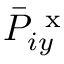Convert formula to latex. <formula><loc_0><loc_0><loc_500><loc_500>\bar { P } _ { i y } ^ { x }</formula> 